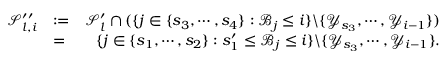Convert formula to latex. <formula><loc_0><loc_0><loc_500><loc_500>\begin{array} { r l r } { \mathcal { S } _ { l , i } ^ { \prime \prime } } & { \colon = } & { \mathcal { S } _ { l } ^ { \prime } \cap ( \{ j \in \{ s _ { 3 } , \cdots , s _ { 4 } \} \colon \ m a t h s c r { B } _ { j } \leq i \} \ \{ \ m a t h s c r { Y } _ { s _ { 3 } } , \cdots , \ m a t h s c r { Y } _ { i - 1 } \} ) } \\ & { = } & { \{ j \in \{ s _ { 1 } , \cdots , s _ { 2 } \} \colon s _ { 1 } ^ { \prime } \leq \ m a t h s c r { B } _ { j } \leq i \} \ \{ \ m a t h s c r { Y } _ { s _ { 3 } } , \cdots , \ m a t h s c r { Y } _ { i - 1 } \} . } \end{array}</formula> 